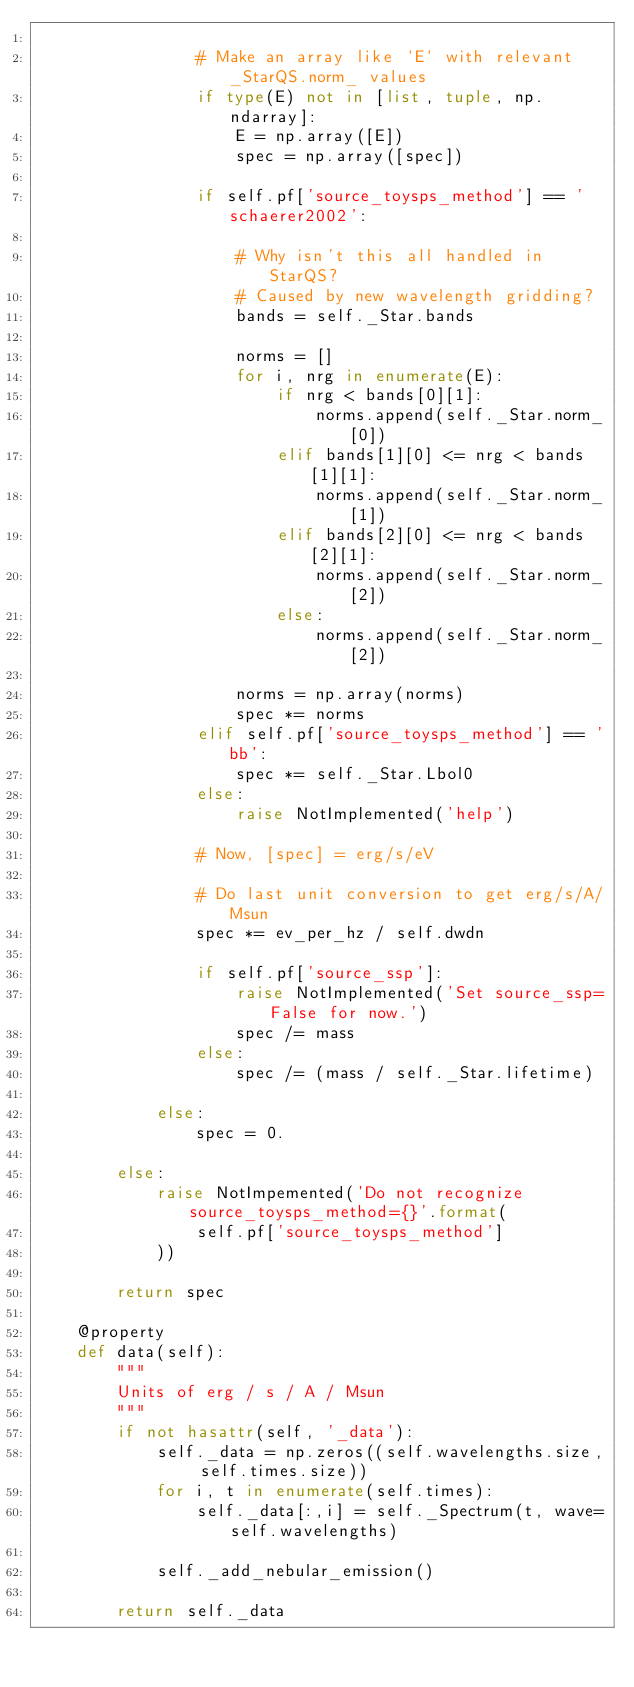Convert code to text. <code><loc_0><loc_0><loc_500><loc_500><_Python_>
                # Make an array like `E` with relevant _StarQS.norm_ values
                if type(E) not in [list, tuple, np.ndarray]:
                    E = np.array([E])
                    spec = np.array([spec])

                if self.pf['source_toysps_method'] == 'schaerer2002':

                    # Why isn't this all handled in StarQS?
                    # Caused by new wavelength gridding?
                    bands = self._Star.bands

                    norms = []
                    for i, nrg in enumerate(E):
                        if nrg < bands[0][1]:
                            norms.append(self._Star.norm_[0])
                        elif bands[1][0] <= nrg < bands[1][1]:
                            norms.append(self._Star.norm_[1])
                        elif bands[2][0] <= nrg < bands[2][1]:
                            norms.append(self._Star.norm_[2])
                        else:
                            norms.append(self._Star.norm_[2])

                    norms = np.array(norms)
                    spec *= norms
                elif self.pf['source_toysps_method'] == 'bb':
                    spec *= self._Star.Lbol0
                else:
                    raise NotImplemented('help')

                # Now, [spec] = erg/s/eV

                # Do last unit conversion to get erg/s/A/Msun
                spec *= ev_per_hz / self.dwdn

                if self.pf['source_ssp']:
                    raise NotImplemented('Set source_ssp=False for now.')
                    spec /= mass
                else:
                    spec /= (mass / self._Star.lifetime)

            else:
                spec = 0.

        else:
            raise NotImpemented('Do not recognize source_toysps_method={}'.format(
                self.pf['source_toysps_method']
            ))

        return spec

    @property
    def data(self):
        """
        Units of erg / s / A / Msun
        """
        if not hasattr(self, '_data'):
            self._data = np.zeros((self.wavelengths.size, self.times.size))
            for i, t in enumerate(self.times):
                self._data[:,i] = self._Spectrum(t, wave=self.wavelengths)

            self._add_nebular_emission()

        return self._data
</code> 